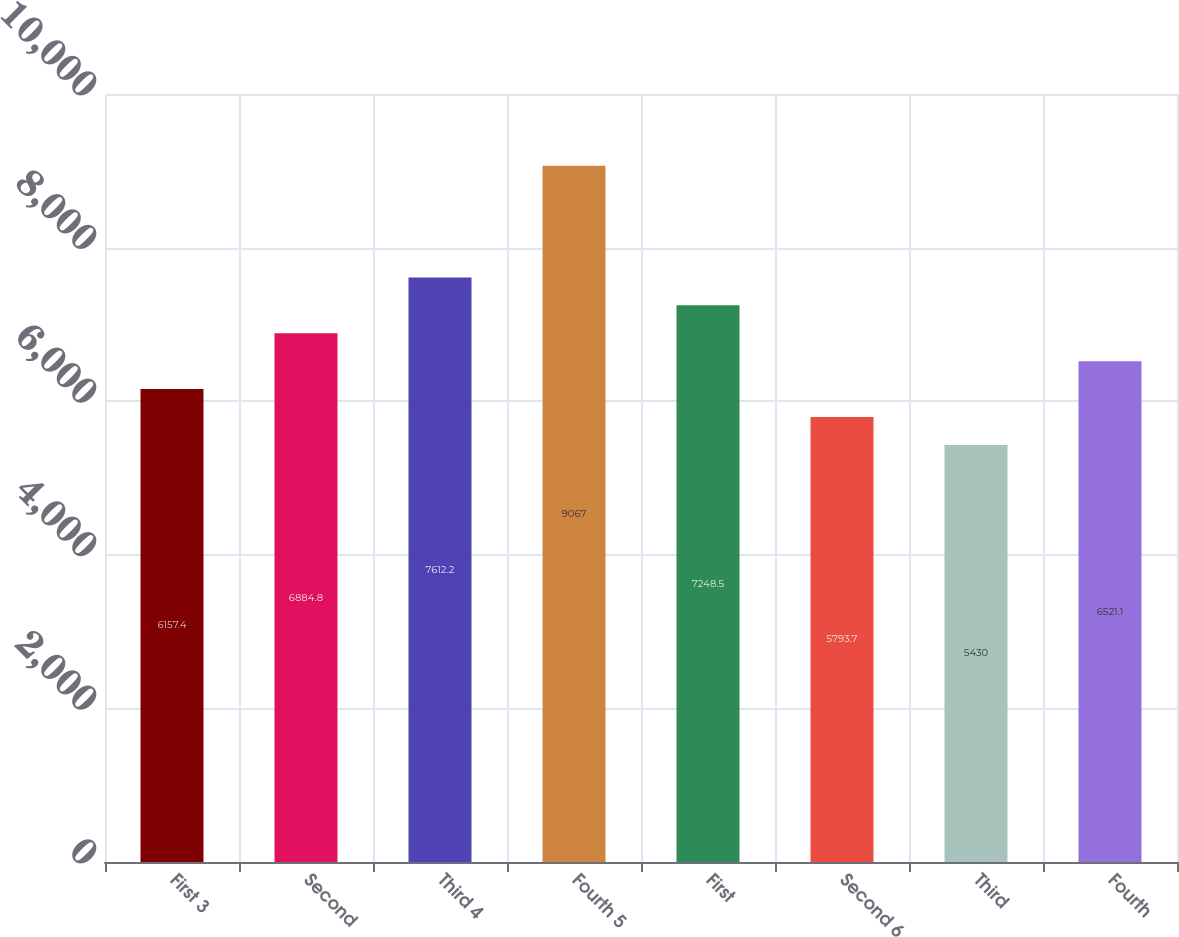<chart> <loc_0><loc_0><loc_500><loc_500><bar_chart><fcel>First 3<fcel>Second<fcel>Third 4<fcel>Fourth 5<fcel>First<fcel>Second 6<fcel>Third<fcel>Fourth<nl><fcel>6157.4<fcel>6884.8<fcel>7612.2<fcel>9067<fcel>7248.5<fcel>5793.7<fcel>5430<fcel>6521.1<nl></chart> 